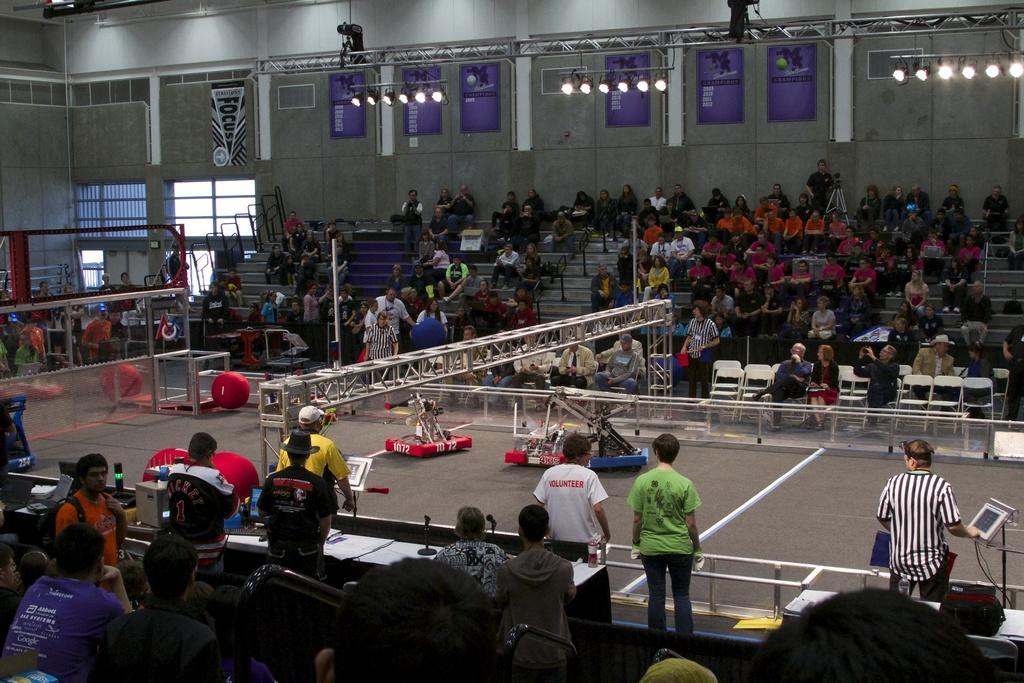Describe this image in one or two sentences. This picture consists of inside view of auditorium and I can see a vehicle visible in the middle and I can see there are some persons visible on stair case and some persons standing and some persons sitting on chairs and at the top I can see lights and the wall. At the bottom I can see a table ,in the middle I can see a rod. 